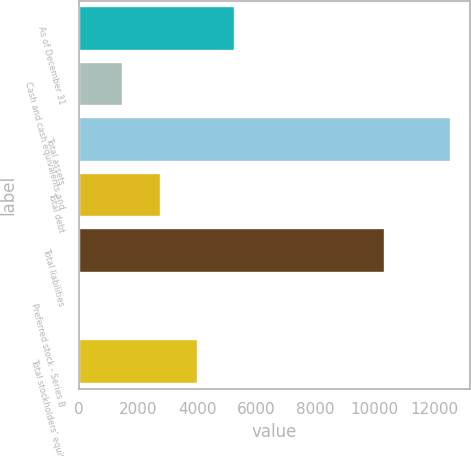<chart> <loc_0><loc_0><loc_500><loc_500><bar_chart><fcel>As of December 31<fcel>Cash and cash equivalents and<fcel>Total assets<fcel>Total debt<fcel>Total liabilities<fcel>Preferred stock - Series B<fcel>Total stockholders' equity<nl><fcel>5284.9<fcel>1509.7<fcel>12585.1<fcel>2768.1<fcel>10331.4<fcel>1.07<fcel>4026.5<nl></chart> 